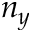<formula> <loc_0><loc_0><loc_500><loc_500>n _ { y }</formula> 